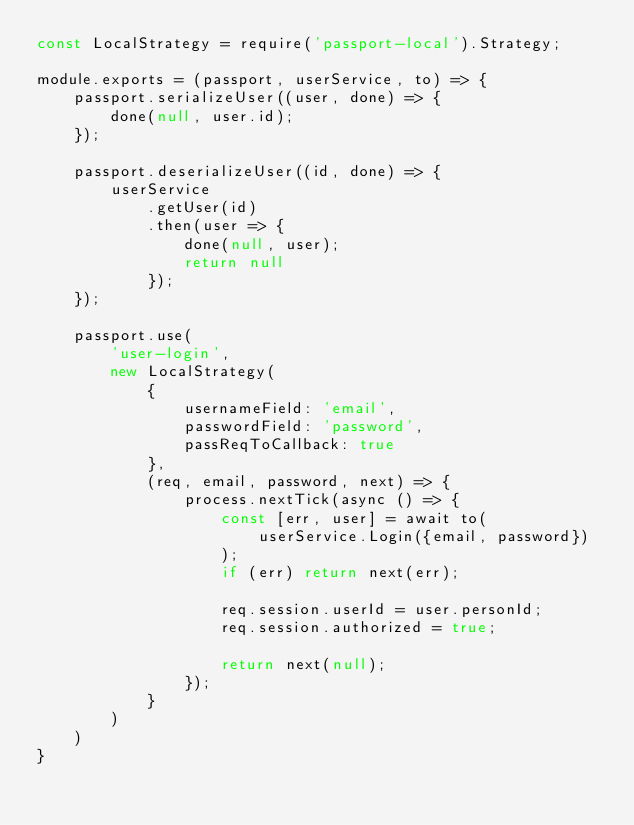Convert code to text. <code><loc_0><loc_0><loc_500><loc_500><_JavaScript_>const LocalStrategy = require('passport-local').Strategy;

module.exports = (passport, userService, to) => {
    passport.serializeUser((user, done) => {
        done(null, user.id);
    });

    passport.deserializeUser((id, done) => {
        userService
            .getUser(id)
            .then(user => {
                done(null, user);
                return null
            });
    });

    passport.use(
        'user-login',
        new LocalStrategy(
            {
                usernameField: 'email',
                passwordField: 'password',
                passReqToCallback: true
            },
            (req, email, password, next) => {
                process.nextTick(async () => {
                    const [err, user] = await to(
                        userService.Login({email, password})
                    );
                    if (err) return next(err);

                    req.session.userId = user.personId;
                    req.session.authorized = true;

                    return next(null);
                });
            }
        )
    )
}</code> 